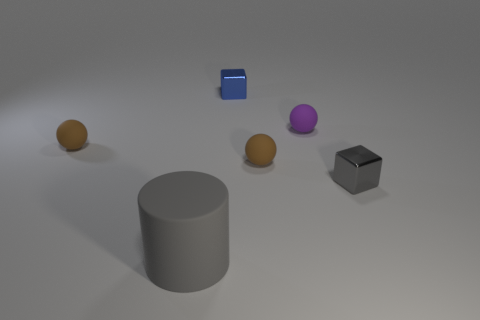Do the small gray object and the brown sphere on the left side of the big gray matte cylinder have the same material?
Your response must be concise. No. The cylinder that is the same material as the tiny purple object is what size?
Make the answer very short. Large. Are there more small blue cubes that are to the left of the gray matte cylinder than small blue metallic blocks that are in front of the small purple sphere?
Ensure brevity in your answer.  No. Are there any brown metallic objects of the same shape as the small purple rubber object?
Give a very brief answer. No. Do the metal cube that is on the left side of the gray shiny thing and the large gray matte cylinder have the same size?
Provide a succinct answer. No. Are there any small brown matte spheres?
Make the answer very short. Yes. How many objects are either blocks behind the tiny purple sphere or big gray matte spheres?
Provide a succinct answer. 1. Does the rubber cylinder have the same color as the object behind the small purple thing?
Make the answer very short. No. Are there any red metallic cylinders that have the same size as the blue metallic object?
Provide a short and direct response. No. There is a block that is in front of the brown matte thing to the left of the gray cylinder; what is its material?
Give a very brief answer. Metal. 